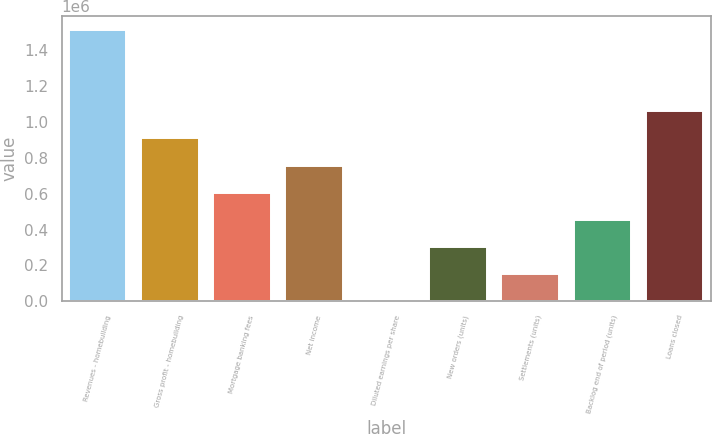Convert chart. <chart><loc_0><loc_0><loc_500><loc_500><bar_chart><fcel>Revenues - homebuilding<fcel>Gross profit - homebuilding<fcel>Mortgage banking fees<fcel>Net income<fcel>Diluted earnings per share<fcel>New orders (units)<fcel>Settlements (units)<fcel>Backlog end of period (units)<fcel>Loans closed<nl><fcel>1.51271e+06<fcel>907642<fcel>605107<fcel>756375<fcel>35.19<fcel>302571<fcel>151303<fcel>453839<fcel>1.05891e+06<nl></chart> 